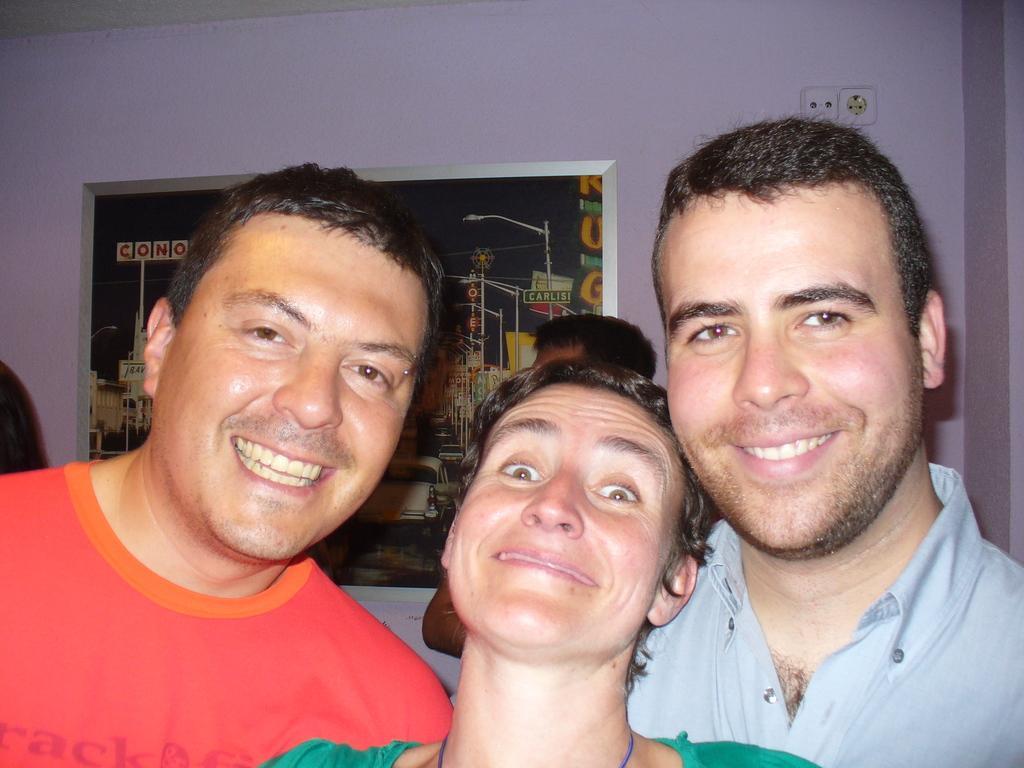In one or two sentences, can you explain what this image depicts? In this image we can see few people. There is a photo on the wall. There is a power socket at the right side of the image. 